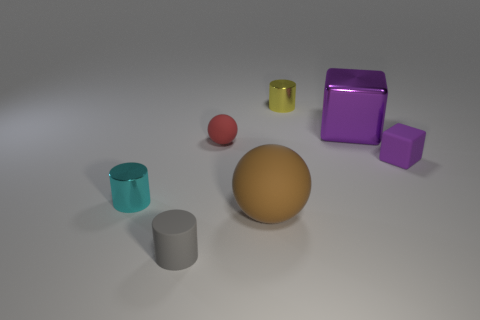There is a purple rubber thing; is its shape the same as the big thing behind the small purple matte block?
Your answer should be compact. Yes. Is the number of small gray rubber things to the left of the tiny red rubber object greater than the number of big brown matte blocks?
Offer a terse response. Yes. Is the number of brown matte objects that are behind the gray cylinder less than the number of purple things?
Provide a succinct answer. Yes. What number of other matte cubes are the same color as the large cube?
Make the answer very short. 1. What is the material of the small thing that is in front of the tiny yellow thing and on the right side of the large brown matte object?
Offer a terse response. Rubber. Is the color of the large object behind the red rubber thing the same as the matte object that is to the right of the large purple block?
Ensure brevity in your answer.  Yes. How many brown things are matte cylinders or big metal blocks?
Offer a terse response. 0. Are there fewer tiny objects on the left side of the large brown ball than objects left of the small yellow thing?
Offer a very short reply. Yes. Is there a cyan cylinder of the same size as the rubber block?
Your answer should be very brief. Yes. Is the size of the matte sphere that is in front of the cyan metallic thing the same as the large purple block?
Offer a very short reply. Yes. 